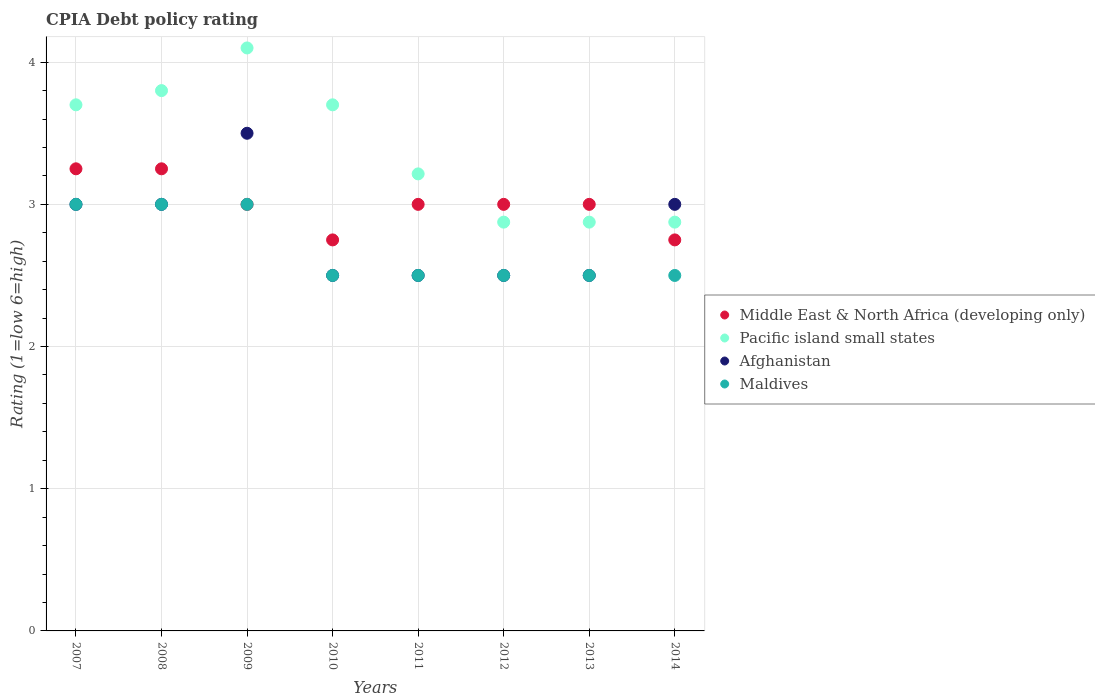How many different coloured dotlines are there?
Your answer should be very brief. 4. Across all years, what is the maximum CPIA rating in Afghanistan?
Give a very brief answer. 3.5. Across all years, what is the minimum CPIA rating in Pacific island small states?
Your answer should be compact. 2.88. In which year was the CPIA rating in Maldives maximum?
Offer a terse response. 2007. What is the average CPIA rating in Maldives per year?
Give a very brief answer. 2.69. In the year 2007, what is the difference between the CPIA rating in Maldives and CPIA rating in Pacific island small states?
Provide a short and direct response. -0.7. In how many years, is the CPIA rating in Middle East & North Africa (developing only) greater than 0.6000000000000001?
Give a very brief answer. 8. What is the ratio of the CPIA rating in Afghanistan in 2012 to that in 2014?
Offer a terse response. 0.83. Is the CPIA rating in Pacific island small states in 2008 less than that in 2013?
Your response must be concise. No. What is the difference between the highest and the second highest CPIA rating in Pacific island small states?
Give a very brief answer. 0.3. What is the difference between the highest and the lowest CPIA rating in Afghanistan?
Offer a very short reply. 1. Is it the case that in every year, the sum of the CPIA rating in Middle East & North Africa (developing only) and CPIA rating in Afghanistan  is greater than the CPIA rating in Pacific island small states?
Keep it short and to the point. Yes. Is the CPIA rating in Maldives strictly greater than the CPIA rating in Afghanistan over the years?
Offer a very short reply. No. Is the CPIA rating in Maldives strictly less than the CPIA rating in Middle East & North Africa (developing only) over the years?
Offer a terse response. No. What is the difference between two consecutive major ticks on the Y-axis?
Provide a short and direct response. 1. Are the values on the major ticks of Y-axis written in scientific E-notation?
Give a very brief answer. No. Does the graph contain any zero values?
Provide a short and direct response. No. Does the graph contain grids?
Provide a succinct answer. Yes. Where does the legend appear in the graph?
Offer a very short reply. Center right. How are the legend labels stacked?
Offer a terse response. Vertical. What is the title of the graph?
Keep it short and to the point. CPIA Debt policy rating. Does "Suriname" appear as one of the legend labels in the graph?
Make the answer very short. No. What is the label or title of the X-axis?
Keep it short and to the point. Years. What is the Rating (1=low 6=high) in Pacific island small states in 2007?
Your answer should be compact. 3.7. What is the Rating (1=low 6=high) in Maldives in 2007?
Your answer should be very brief. 3. What is the Rating (1=low 6=high) in Middle East & North Africa (developing only) in 2008?
Your response must be concise. 3.25. What is the Rating (1=low 6=high) in Maldives in 2008?
Your answer should be very brief. 3. What is the Rating (1=low 6=high) in Pacific island small states in 2009?
Provide a short and direct response. 4.1. What is the Rating (1=low 6=high) of Afghanistan in 2009?
Your response must be concise. 3.5. What is the Rating (1=low 6=high) of Maldives in 2009?
Provide a short and direct response. 3. What is the Rating (1=low 6=high) of Middle East & North Africa (developing only) in 2010?
Your answer should be very brief. 2.75. What is the Rating (1=low 6=high) in Pacific island small states in 2011?
Ensure brevity in your answer.  3.21. What is the Rating (1=low 6=high) of Afghanistan in 2011?
Keep it short and to the point. 2.5. What is the Rating (1=low 6=high) in Pacific island small states in 2012?
Ensure brevity in your answer.  2.88. What is the Rating (1=low 6=high) of Afghanistan in 2012?
Provide a short and direct response. 2.5. What is the Rating (1=low 6=high) of Middle East & North Africa (developing only) in 2013?
Offer a terse response. 3. What is the Rating (1=low 6=high) in Pacific island small states in 2013?
Give a very brief answer. 2.88. What is the Rating (1=low 6=high) of Afghanistan in 2013?
Offer a terse response. 2.5. What is the Rating (1=low 6=high) in Maldives in 2013?
Ensure brevity in your answer.  2.5. What is the Rating (1=low 6=high) of Middle East & North Africa (developing only) in 2014?
Offer a terse response. 2.75. What is the Rating (1=low 6=high) in Pacific island small states in 2014?
Ensure brevity in your answer.  2.88. What is the Rating (1=low 6=high) of Afghanistan in 2014?
Offer a terse response. 3. Across all years, what is the maximum Rating (1=low 6=high) of Pacific island small states?
Your answer should be very brief. 4.1. Across all years, what is the maximum Rating (1=low 6=high) of Afghanistan?
Ensure brevity in your answer.  3.5. Across all years, what is the minimum Rating (1=low 6=high) in Middle East & North Africa (developing only)?
Offer a terse response. 2.75. Across all years, what is the minimum Rating (1=low 6=high) of Pacific island small states?
Your answer should be compact. 2.88. Across all years, what is the minimum Rating (1=low 6=high) of Afghanistan?
Offer a terse response. 2.5. Across all years, what is the minimum Rating (1=low 6=high) in Maldives?
Your answer should be compact. 2.5. What is the total Rating (1=low 6=high) of Pacific island small states in the graph?
Give a very brief answer. 27.14. What is the difference between the Rating (1=low 6=high) in Pacific island small states in 2007 and that in 2008?
Your answer should be very brief. -0.1. What is the difference between the Rating (1=low 6=high) of Afghanistan in 2007 and that in 2009?
Offer a terse response. -0.5. What is the difference between the Rating (1=low 6=high) in Maldives in 2007 and that in 2009?
Your answer should be very brief. 0. What is the difference between the Rating (1=low 6=high) of Afghanistan in 2007 and that in 2010?
Keep it short and to the point. 0.5. What is the difference between the Rating (1=low 6=high) in Pacific island small states in 2007 and that in 2011?
Provide a succinct answer. 0.49. What is the difference between the Rating (1=low 6=high) of Middle East & North Africa (developing only) in 2007 and that in 2012?
Offer a terse response. 0.25. What is the difference between the Rating (1=low 6=high) in Pacific island small states in 2007 and that in 2012?
Your response must be concise. 0.82. What is the difference between the Rating (1=low 6=high) in Afghanistan in 2007 and that in 2012?
Your answer should be compact. 0.5. What is the difference between the Rating (1=low 6=high) of Maldives in 2007 and that in 2012?
Offer a very short reply. 0.5. What is the difference between the Rating (1=low 6=high) in Middle East & North Africa (developing only) in 2007 and that in 2013?
Your response must be concise. 0.25. What is the difference between the Rating (1=low 6=high) in Pacific island small states in 2007 and that in 2013?
Make the answer very short. 0.82. What is the difference between the Rating (1=low 6=high) in Afghanistan in 2007 and that in 2013?
Ensure brevity in your answer.  0.5. What is the difference between the Rating (1=low 6=high) of Pacific island small states in 2007 and that in 2014?
Offer a very short reply. 0.82. What is the difference between the Rating (1=low 6=high) in Maldives in 2007 and that in 2014?
Your answer should be compact. 0.5. What is the difference between the Rating (1=low 6=high) of Middle East & North Africa (developing only) in 2008 and that in 2009?
Ensure brevity in your answer.  0.25. What is the difference between the Rating (1=low 6=high) of Maldives in 2008 and that in 2010?
Ensure brevity in your answer.  0.5. What is the difference between the Rating (1=low 6=high) in Pacific island small states in 2008 and that in 2011?
Your answer should be very brief. 0.59. What is the difference between the Rating (1=low 6=high) of Afghanistan in 2008 and that in 2011?
Your response must be concise. 0.5. What is the difference between the Rating (1=low 6=high) in Maldives in 2008 and that in 2011?
Give a very brief answer. 0.5. What is the difference between the Rating (1=low 6=high) of Middle East & North Africa (developing only) in 2008 and that in 2012?
Give a very brief answer. 0.25. What is the difference between the Rating (1=low 6=high) in Pacific island small states in 2008 and that in 2012?
Your answer should be very brief. 0.93. What is the difference between the Rating (1=low 6=high) of Afghanistan in 2008 and that in 2012?
Provide a succinct answer. 0.5. What is the difference between the Rating (1=low 6=high) in Pacific island small states in 2008 and that in 2013?
Your answer should be very brief. 0.93. What is the difference between the Rating (1=low 6=high) in Afghanistan in 2008 and that in 2013?
Provide a short and direct response. 0.5. What is the difference between the Rating (1=low 6=high) of Maldives in 2008 and that in 2013?
Provide a succinct answer. 0.5. What is the difference between the Rating (1=low 6=high) of Middle East & North Africa (developing only) in 2008 and that in 2014?
Ensure brevity in your answer.  0.5. What is the difference between the Rating (1=low 6=high) in Pacific island small states in 2008 and that in 2014?
Make the answer very short. 0.93. What is the difference between the Rating (1=low 6=high) in Afghanistan in 2008 and that in 2014?
Provide a short and direct response. 0. What is the difference between the Rating (1=low 6=high) of Maldives in 2008 and that in 2014?
Offer a terse response. 0.5. What is the difference between the Rating (1=low 6=high) of Middle East & North Africa (developing only) in 2009 and that in 2010?
Make the answer very short. 0.25. What is the difference between the Rating (1=low 6=high) of Pacific island small states in 2009 and that in 2010?
Give a very brief answer. 0.4. What is the difference between the Rating (1=low 6=high) of Afghanistan in 2009 and that in 2010?
Keep it short and to the point. 1. What is the difference between the Rating (1=low 6=high) of Middle East & North Africa (developing only) in 2009 and that in 2011?
Ensure brevity in your answer.  0. What is the difference between the Rating (1=low 6=high) in Pacific island small states in 2009 and that in 2011?
Ensure brevity in your answer.  0.89. What is the difference between the Rating (1=low 6=high) of Afghanistan in 2009 and that in 2011?
Provide a short and direct response. 1. What is the difference between the Rating (1=low 6=high) of Maldives in 2009 and that in 2011?
Provide a succinct answer. 0.5. What is the difference between the Rating (1=low 6=high) in Pacific island small states in 2009 and that in 2012?
Make the answer very short. 1.23. What is the difference between the Rating (1=low 6=high) in Pacific island small states in 2009 and that in 2013?
Ensure brevity in your answer.  1.23. What is the difference between the Rating (1=low 6=high) in Afghanistan in 2009 and that in 2013?
Offer a terse response. 1. What is the difference between the Rating (1=low 6=high) in Middle East & North Africa (developing only) in 2009 and that in 2014?
Ensure brevity in your answer.  0.25. What is the difference between the Rating (1=low 6=high) of Pacific island small states in 2009 and that in 2014?
Offer a very short reply. 1.23. What is the difference between the Rating (1=low 6=high) of Middle East & North Africa (developing only) in 2010 and that in 2011?
Make the answer very short. -0.25. What is the difference between the Rating (1=low 6=high) of Pacific island small states in 2010 and that in 2011?
Provide a short and direct response. 0.49. What is the difference between the Rating (1=low 6=high) of Afghanistan in 2010 and that in 2011?
Provide a succinct answer. 0. What is the difference between the Rating (1=low 6=high) in Maldives in 2010 and that in 2011?
Give a very brief answer. 0. What is the difference between the Rating (1=low 6=high) of Middle East & North Africa (developing only) in 2010 and that in 2012?
Provide a succinct answer. -0.25. What is the difference between the Rating (1=low 6=high) of Pacific island small states in 2010 and that in 2012?
Ensure brevity in your answer.  0.82. What is the difference between the Rating (1=low 6=high) in Afghanistan in 2010 and that in 2012?
Offer a very short reply. 0. What is the difference between the Rating (1=low 6=high) of Pacific island small states in 2010 and that in 2013?
Your answer should be compact. 0.82. What is the difference between the Rating (1=low 6=high) in Afghanistan in 2010 and that in 2013?
Make the answer very short. 0. What is the difference between the Rating (1=low 6=high) of Maldives in 2010 and that in 2013?
Give a very brief answer. 0. What is the difference between the Rating (1=low 6=high) of Middle East & North Africa (developing only) in 2010 and that in 2014?
Offer a terse response. 0. What is the difference between the Rating (1=low 6=high) of Pacific island small states in 2010 and that in 2014?
Provide a short and direct response. 0.82. What is the difference between the Rating (1=low 6=high) in Pacific island small states in 2011 and that in 2012?
Ensure brevity in your answer.  0.34. What is the difference between the Rating (1=low 6=high) in Maldives in 2011 and that in 2012?
Provide a short and direct response. 0. What is the difference between the Rating (1=low 6=high) in Middle East & North Africa (developing only) in 2011 and that in 2013?
Give a very brief answer. 0. What is the difference between the Rating (1=low 6=high) in Pacific island small states in 2011 and that in 2013?
Your answer should be compact. 0.34. What is the difference between the Rating (1=low 6=high) in Maldives in 2011 and that in 2013?
Your answer should be compact. 0. What is the difference between the Rating (1=low 6=high) of Pacific island small states in 2011 and that in 2014?
Give a very brief answer. 0.34. What is the difference between the Rating (1=low 6=high) of Afghanistan in 2011 and that in 2014?
Your response must be concise. -0.5. What is the difference between the Rating (1=low 6=high) of Maldives in 2011 and that in 2014?
Offer a very short reply. 0. What is the difference between the Rating (1=low 6=high) of Pacific island small states in 2012 and that in 2013?
Your answer should be very brief. 0. What is the difference between the Rating (1=low 6=high) of Afghanistan in 2012 and that in 2013?
Make the answer very short. 0. What is the difference between the Rating (1=low 6=high) in Middle East & North Africa (developing only) in 2012 and that in 2014?
Your response must be concise. 0.25. What is the difference between the Rating (1=low 6=high) of Pacific island small states in 2012 and that in 2014?
Ensure brevity in your answer.  0. What is the difference between the Rating (1=low 6=high) in Afghanistan in 2012 and that in 2014?
Offer a terse response. -0.5. What is the difference between the Rating (1=low 6=high) in Middle East & North Africa (developing only) in 2013 and that in 2014?
Your response must be concise. 0.25. What is the difference between the Rating (1=low 6=high) of Middle East & North Africa (developing only) in 2007 and the Rating (1=low 6=high) of Pacific island small states in 2008?
Provide a short and direct response. -0.55. What is the difference between the Rating (1=low 6=high) of Middle East & North Africa (developing only) in 2007 and the Rating (1=low 6=high) of Afghanistan in 2008?
Ensure brevity in your answer.  0.25. What is the difference between the Rating (1=low 6=high) in Pacific island small states in 2007 and the Rating (1=low 6=high) in Afghanistan in 2008?
Your answer should be very brief. 0.7. What is the difference between the Rating (1=low 6=high) of Pacific island small states in 2007 and the Rating (1=low 6=high) of Maldives in 2008?
Provide a succinct answer. 0.7. What is the difference between the Rating (1=low 6=high) in Afghanistan in 2007 and the Rating (1=low 6=high) in Maldives in 2008?
Make the answer very short. 0. What is the difference between the Rating (1=low 6=high) of Middle East & North Africa (developing only) in 2007 and the Rating (1=low 6=high) of Pacific island small states in 2009?
Provide a succinct answer. -0.85. What is the difference between the Rating (1=low 6=high) in Middle East & North Africa (developing only) in 2007 and the Rating (1=low 6=high) in Afghanistan in 2009?
Your answer should be very brief. -0.25. What is the difference between the Rating (1=low 6=high) of Pacific island small states in 2007 and the Rating (1=low 6=high) of Afghanistan in 2009?
Give a very brief answer. 0.2. What is the difference between the Rating (1=low 6=high) of Pacific island small states in 2007 and the Rating (1=low 6=high) of Maldives in 2009?
Provide a short and direct response. 0.7. What is the difference between the Rating (1=low 6=high) in Afghanistan in 2007 and the Rating (1=low 6=high) in Maldives in 2009?
Your response must be concise. 0. What is the difference between the Rating (1=low 6=high) in Middle East & North Africa (developing only) in 2007 and the Rating (1=low 6=high) in Pacific island small states in 2010?
Keep it short and to the point. -0.45. What is the difference between the Rating (1=low 6=high) of Pacific island small states in 2007 and the Rating (1=low 6=high) of Afghanistan in 2010?
Keep it short and to the point. 1.2. What is the difference between the Rating (1=low 6=high) of Middle East & North Africa (developing only) in 2007 and the Rating (1=low 6=high) of Pacific island small states in 2011?
Provide a short and direct response. 0.04. What is the difference between the Rating (1=low 6=high) in Middle East & North Africa (developing only) in 2007 and the Rating (1=low 6=high) in Afghanistan in 2011?
Provide a succinct answer. 0.75. What is the difference between the Rating (1=low 6=high) of Middle East & North Africa (developing only) in 2007 and the Rating (1=low 6=high) of Maldives in 2011?
Offer a very short reply. 0.75. What is the difference between the Rating (1=low 6=high) of Afghanistan in 2007 and the Rating (1=low 6=high) of Maldives in 2011?
Your response must be concise. 0.5. What is the difference between the Rating (1=low 6=high) of Middle East & North Africa (developing only) in 2007 and the Rating (1=low 6=high) of Afghanistan in 2012?
Keep it short and to the point. 0.75. What is the difference between the Rating (1=low 6=high) of Middle East & North Africa (developing only) in 2007 and the Rating (1=low 6=high) of Maldives in 2012?
Your response must be concise. 0.75. What is the difference between the Rating (1=low 6=high) in Pacific island small states in 2007 and the Rating (1=low 6=high) in Afghanistan in 2012?
Make the answer very short. 1.2. What is the difference between the Rating (1=low 6=high) of Pacific island small states in 2007 and the Rating (1=low 6=high) of Maldives in 2012?
Give a very brief answer. 1.2. What is the difference between the Rating (1=low 6=high) of Afghanistan in 2007 and the Rating (1=low 6=high) of Maldives in 2012?
Your response must be concise. 0.5. What is the difference between the Rating (1=low 6=high) of Middle East & North Africa (developing only) in 2007 and the Rating (1=low 6=high) of Afghanistan in 2013?
Offer a very short reply. 0.75. What is the difference between the Rating (1=low 6=high) of Pacific island small states in 2007 and the Rating (1=low 6=high) of Afghanistan in 2013?
Ensure brevity in your answer.  1.2. What is the difference between the Rating (1=low 6=high) in Pacific island small states in 2007 and the Rating (1=low 6=high) in Maldives in 2013?
Make the answer very short. 1.2. What is the difference between the Rating (1=low 6=high) of Middle East & North Africa (developing only) in 2007 and the Rating (1=low 6=high) of Pacific island small states in 2014?
Your response must be concise. 0.38. What is the difference between the Rating (1=low 6=high) of Middle East & North Africa (developing only) in 2007 and the Rating (1=low 6=high) of Afghanistan in 2014?
Provide a short and direct response. 0.25. What is the difference between the Rating (1=low 6=high) of Middle East & North Africa (developing only) in 2007 and the Rating (1=low 6=high) of Maldives in 2014?
Offer a terse response. 0.75. What is the difference between the Rating (1=low 6=high) of Pacific island small states in 2007 and the Rating (1=low 6=high) of Afghanistan in 2014?
Provide a short and direct response. 0.7. What is the difference between the Rating (1=low 6=high) of Pacific island small states in 2007 and the Rating (1=low 6=high) of Maldives in 2014?
Provide a succinct answer. 1.2. What is the difference between the Rating (1=low 6=high) in Afghanistan in 2007 and the Rating (1=low 6=high) in Maldives in 2014?
Your response must be concise. 0.5. What is the difference between the Rating (1=low 6=high) of Middle East & North Africa (developing only) in 2008 and the Rating (1=low 6=high) of Pacific island small states in 2009?
Keep it short and to the point. -0.85. What is the difference between the Rating (1=low 6=high) in Pacific island small states in 2008 and the Rating (1=low 6=high) in Maldives in 2009?
Your answer should be very brief. 0.8. What is the difference between the Rating (1=low 6=high) in Afghanistan in 2008 and the Rating (1=low 6=high) in Maldives in 2009?
Offer a very short reply. 0. What is the difference between the Rating (1=low 6=high) of Middle East & North Africa (developing only) in 2008 and the Rating (1=low 6=high) of Pacific island small states in 2010?
Give a very brief answer. -0.45. What is the difference between the Rating (1=low 6=high) in Middle East & North Africa (developing only) in 2008 and the Rating (1=low 6=high) in Afghanistan in 2010?
Offer a terse response. 0.75. What is the difference between the Rating (1=low 6=high) of Middle East & North Africa (developing only) in 2008 and the Rating (1=low 6=high) of Maldives in 2010?
Provide a short and direct response. 0.75. What is the difference between the Rating (1=low 6=high) in Pacific island small states in 2008 and the Rating (1=low 6=high) in Afghanistan in 2010?
Your answer should be very brief. 1.3. What is the difference between the Rating (1=low 6=high) of Afghanistan in 2008 and the Rating (1=low 6=high) of Maldives in 2010?
Offer a terse response. 0.5. What is the difference between the Rating (1=low 6=high) of Middle East & North Africa (developing only) in 2008 and the Rating (1=low 6=high) of Pacific island small states in 2011?
Keep it short and to the point. 0.04. What is the difference between the Rating (1=low 6=high) in Pacific island small states in 2008 and the Rating (1=low 6=high) in Afghanistan in 2011?
Provide a short and direct response. 1.3. What is the difference between the Rating (1=low 6=high) of Pacific island small states in 2008 and the Rating (1=low 6=high) of Maldives in 2011?
Offer a terse response. 1.3. What is the difference between the Rating (1=low 6=high) of Middle East & North Africa (developing only) in 2008 and the Rating (1=low 6=high) of Maldives in 2012?
Ensure brevity in your answer.  0.75. What is the difference between the Rating (1=low 6=high) in Pacific island small states in 2008 and the Rating (1=low 6=high) in Maldives in 2012?
Offer a terse response. 1.3. What is the difference between the Rating (1=low 6=high) of Afghanistan in 2008 and the Rating (1=low 6=high) of Maldives in 2012?
Your answer should be very brief. 0.5. What is the difference between the Rating (1=low 6=high) in Middle East & North Africa (developing only) in 2008 and the Rating (1=low 6=high) in Pacific island small states in 2013?
Provide a succinct answer. 0.38. What is the difference between the Rating (1=low 6=high) of Middle East & North Africa (developing only) in 2008 and the Rating (1=low 6=high) of Afghanistan in 2013?
Ensure brevity in your answer.  0.75. What is the difference between the Rating (1=low 6=high) of Pacific island small states in 2008 and the Rating (1=low 6=high) of Afghanistan in 2013?
Offer a very short reply. 1.3. What is the difference between the Rating (1=low 6=high) in Pacific island small states in 2008 and the Rating (1=low 6=high) in Maldives in 2013?
Offer a very short reply. 1.3. What is the difference between the Rating (1=low 6=high) of Middle East & North Africa (developing only) in 2008 and the Rating (1=low 6=high) of Pacific island small states in 2014?
Provide a short and direct response. 0.38. What is the difference between the Rating (1=low 6=high) of Middle East & North Africa (developing only) in 2008 and the Rating (1=low 6=high) of Maldives in 2014?
Provide a succinct answer. 0.75. What is the difference between the Rating (1=low 6=high) in Middle East & North Africa (developing only) in 2009 and the Rating (1=low 6=high) in Pacific island small states in 2010?
Give a very brief answer. -0.7. What is the difference between the Rating (1=low 6=high) of Middle East & North Africa (developing only) in 2009 and the Rating (1=low 6=high) of Afghanistan in 2010?
Provide a succinct answer. 0.5. What is the difference between the Rating (1=low 6=high) of Middle East & North Africa (developing only) in 2009 and the Rating (1=low 6=high) of Maldives in 2010?
Give a very brief answer. 0.5. What is the difference between the Rating (1=low 6=high) in Pacific island small states in 2009 and the Rating (1=low 6=high) in Afghanistan in 2010?
Offer a very short reply. 1.6. What is the difference between the Rating (1=low 6=high) in Pacific island small states in 2009 and the Rating (1=low 6=high) in Maldives in 2010?
Ensure brevity in your answer.  1.6. What is the difference between the Rating (1=low 6=high) in Afghanistan in 2009 and the Rating (1=low 6=high) in Maldives in 2010?
Keep it short and to the point. 1. What is the difference between the Rating (1=low 6=high) of Middle East & North Africa (developing only) in 2009 and the Rating (1=low 6=high) of Pacific island small states in 2011?
Your response must be concise. -0.21. What is the difference between the Rating (1=low 6=high) in Middle East & North Africa (developing only) in 2009 and the Rating (1=low 6=high) in Afghanistan in 2011?
Your answer should be compact. 0.5. What is the difference between the Rating (1=low 6=high) in Middle East & North Africa (developing only) in 2009 and the Rating (1=low 6=high) in Maldives in 2011?
Give a very brief answer. 0.5. What is the difference between the Rating (1=low 6=high) in Pacific island small states in 2009 and the Rating (1=low 6=high) in Afghanistan in 2011?
Provide a short and direct response. 1.6. What is the difference between the Rating (1=low 6=high) in Afghanistan in 2009 and the Rating (1=low 6=high) in Maldives in 2011?
Provide a short and direct response. 1. What is the difference between the Rating (1=low 6=high) of Middle East & North Africa (developing only) in 2009 and the Rating (1=low 6=high) of Maldives in 2012?
Keep it short and to the point. 0.5. What is the difference between the Rating (1=low 6=high) of Pacific island small states in 2009 and the Rating (1=low 6=high) of Afghanistan in 2012?
Ensure brevity in your answer.  1.6. What is the difference between the Rating (1=low 6=high) in Pacific island small states in 2009 and the Rating (1=low 6=high) in Maldives in 2012?
Offer a terse response. 1.6. What is the difference between the Rating (1=low 6=high) in Middle East & North Africa (developing only) in 2009 and the Rating (1=low 6=high) in Afghanistan in 2013?
Provide a short and direct response. 0.5. What is the difference between the Rating (1=low 6=high) of Middle East & North Africa (developing only) in 2009 and the Rating (1=low 6=high) of Maldives in 2013?
Your answer should be compact. 0.5. What is the difference between the Rating (1=low 6=high) in Pacific island small states in 2009 and the Rating (1=low 6=high) in Afghanistan in 2013?
Provide a short and direct response. 1.6. What is the difference between the Rating (1=low 6=high) in Afghanistan in 2009 and the Rating (1=low 6=high) in Maldives in 2013?
Give a very brief answer. 1. What is the difference between the Rating (1=low 6=high) in Middle East & North Africa (developing only) in 2009 and the Rating (1=low 6=high) in Afghanistan in 2014?
Make the answer very short. 0. What is the difference between the Rating (1=low 6=high) of Middle East & North Africa (developing only) in 2009 and the Rating (1=low 6=high) of Maldives in 2014?
Keep it short and to the point. 0.5. What is the difference between the Rating (1=low 6=high) of Pacific island small states in 2009 and the Rating (1=low 6=high) of Maldives in 2014?
Your answer should be very brief. 1.6. What is the difference between the Rating (1=low 6=high) of Middle East & North Africa (developing only) in 2010 and the Rating (1=low 6=high) of Pacific island small states in 2011?
Provide a short and direct response. -0.46. What is the difference between the Rating (1=low 6=high) of Middle East & North Africa (developing only) in 2010 and the Rating (1=low 6=high) of Pacific island small states in 2012?
Give a very brief answer. -0.12. What is the difference between the Rating (1=low 6=high) of Middle East & North Africa (developing only) in 2010 and the Rating (1=low 6=high) of Afghanistan in 2012?
Give a very brief answer. 0.25. What is the difference between the Rating (1=low 6=high) in Afghanistan in 2010 and the Rating (1=low 6=high) in Maldives in 2012?
Ensure brevity in your answer.  0. What is the difference between the Rating (1=low 6=high) in Middle East & North Africa (developing only) in 2010 and the Rating (1=low 6=high) in Pacific island small states in 2013?
Make the answer very short. -0.12. What is the difference between the Rating (1=low 6=high) in Middle East & North Africa (developing only) in 2010 and the Rating (1=low 6=high) in Afghanistan in 2013?
Your response must be concise. 0.25. What is the difference between the Rating (1=low 6=high) of Middle East & North Africa (developing only) in 2010 and the Rating (1=low 6=high) of Maldives in 2013?
Provide a succinct answer. 0.25. What is the difference between the Rating (1=low 6=high) in Pacific island small states in 2010 and the Rating (1=low 6=high) in Maldives in 2013?
Offer a terse response. 1.2. What is the difference between the Rating (1=low 6=high) in Middle East & North Africa (developing only) in 2010 and the Rating (1=low 6=high) in Pacific island small states in 2014?
Make the answer very short. -0.12. What is the difference between the Rating (1=low 6=high) in Pacific island small states in 2010 and the Rating (1=low 6=high) in Maldives in 2014?
Offer a very short reply. 1.2. What is the difference between the Rating (1=low 6=high) in Middle East & North Africa (developing only) in 2011 and the Rating (1=low 6=high) in Pacific island small states in 2012?
Offer a terse response. 0.12. What is the difference between the Rating (1=low 6=high) in Middle East & North Africa (developing only) in 2011 and the Rating (1=low 6=high) in Maldives in 2012?
Offer a terse response. 0.5. What is the difference between the Rating (1=low 6=high) in Pacific island small states in 2011 and the Rating (1=low 6=high) in Afghanistan in 2012?
Give a very brief answer. 0.71. What is the difference between the Rating (1=low 6=high) of Afghanistan in 2011 and the Rating (1=low 6=high) of Maldives in 2012?
Your answer should be compact. 0. What is the difference between the Rating (1=low 6=high) in Middle East & North Africa (developing only) in 2011 and the Rating (1=low 6=high) in Pacific island small states in 2013?
Your response must be concise. 0.12. What is the difference between the Rating (1=low 6=high) in Middle East & North Africa (developing only) in 2011 and the Rating (1=low 6=high) in Afghanistan in 2013?
Offer a terse response. 0.5. What is the difference between the Rating (1=low 6=high) in Middle East & North Africa (developing only) in 2011 and the Rating (1=low 6=high) in Maldives in 2013?
Your answer should be very brief. 0.5. What is the difference between the Rating (1=low 6=high) in Middle East & North Africa (developing only) in 2011 and the Rating (1=low 6=high) in Pacific island small states in 2014?
Your answer should be compact. 0.12. What is the difference between the Rating (1=low 6=high) of Middle East & North Africa (developing only) in 2011 and the Rating (1=low 6=high) of Afghanistan in 2014?
Offer a terse response. 0. What is the difference between the Rating (1=low 6=high) in Middle East & North Africa (developing only) in 2011 and the Rating (1=low 6=high) in Maldives in 2014?
Keep it short and to the point. 0.5. What is the difference between the Rating (1=low 6=high) of Pacific island small states in 2011 and the Rating (1=low 6=high) of Afghanistan in 2014?
Your answer should be very brief. 0.21. What is the difference between the Rating (1=low 6=high) in Afghanistan in 2011 and the Rating (1=low 6=high) in Maldives in 2014?
Your answer should be very brief. 0. What is the difference between the Rating (1=low 6=high) in Middle East & North Africa (developing only) in 2012 and the Rating (1=low 6=high) in Afghanistan in 2013?
Give a very brief answer. 0.5. What is the difference between the Rating (1=low 6=high) of Middle East & North Africa (developing only) in 2012 and the Rating (1=low 6=high) of Maldives in 2013?
Keep it short and to the point. 0.5. What is the difference between the Rating (1=low 6=high) in Pacific island small states in 2012 and the Rating (1=low 6=high) in Afghanistan in 2013?
Ensure brevity in your answer.  0.38. What is the difference between the Rating (1=low 6=high) of Pacific island small states in 2012 and the Rating (1=low 6=high) of Maldives in 2013?
Your response must be concise. 0.38. What is the difference between the Rating (1=low 6=high) in Middle East & North Africa (developing only) in 2012 and the Rating (1=low 6=high) in Afghanistan in 2014?
Offer a very short reply. 0. What is the difference between the Rating (1=low 6=high) of Middle East & North Africa (developing only) in 2012 and the Rating (1=low 6=high) of Maldives in 2014?
Your answer should be very brief. 0.5. What is the difference between the Rating (1=low 6=high) in Pacific island small states in 2012 and the Rating (1=low 6=high) in Afghanistan in 2014?
Provide a short and direct response. -0.12. What is the difference between the Rating (1=low 6=high) in Pacific island small states in 2012 and the Rating (1=low 6=high) in Maldives in 2014?
Keep it short and to the point. 0.38. What is the difference between the Rating (1=low 6=high) in Afghanistan in 2012 and the Rating (1=low 6=high) in Maldives in 2014?
Keep it short and to the point. 0. What is the difference between the Rating (1=low 6=high) of Middle East & North Africa (developing only) in 2013 and the Rating (1=low 6=high) of Pacific island small states in 2014?
Give a very brief answer. 0.12. What is the difference between the Rating (1=low 6=high) of Middle East & North Africa (developing only) in 2013 and the Rating (1=low 6=high) of Maldives in 2014?
Ensure brevity in your answer.  0.5. What is the difference between the Rating (1=low 6=high) of Pacific island small states in 2013 and the Rating (1=low 6=high) of Afghanistan in 2014?
Offer a terse response. -0.12. What is the difference between the Rating (1=low 6=high) in Pacific island small states in 2013 and the Rating (1=low 6=high) in Maldives in 2014?
Give a very brief answer. 0.38. What is the difference between the Rating (1=low 6=high) in Afghanistan in 2013 and the Rating (1=low 6=high) in Maldives in 2014?
Your answer should be very brief. 0. What is the average Rating (1=low 6=high) in Pacific island small states per year?
Provide a short and direct response. 3.39. What is the average Rating (1=low 6=high) in Afghanistan per year?
Offer a terse response. 2.81. What is the average Rating (1=low 6=high) of Maldives per year?
Your response must be concise. 2.69. In the year 2007, what is the difference between the Rating (1=low 6=high) of Middle East & North Africa (developing only) and Rating (1=low 6=high) of Pacific island small states?
Ensure brevity in your answer.  -0.45. In the year 2007, what is the difference between the Rating (1=low 6=high) in Pacific island small states and Rating (1=low 6=high) in Maldives?
Keep it short and to the point. 0.7. In the year 2007, what is the difference between the Rating (1=low 6=high) in Afghanistan and Rating (1=low 6=high) in Maldives?
Your answer should be very brief. 0. In the year 2008, what is the difference between the Rating (1=low 6=high) of Middle East & North Africa (developing only) and Rating (1=low 6=high) of Pacific island small states?
Make the answer very short. -0.55. In the year 2008, what is the difference between the Rating (1=low 6=high) in Middle East & North Africa (developing only) and Rating (1=low 6=high) in Maldives?
Keep it short and to the point. 0.25. In the year 2008, what is the difference between the Rating (1=low 6=high) in Afghanistan and Rating (1=low 6=high) in Maldives?
Provide a short and direct response. 0. In the year 2009, what is the difference between the Rating (1=low 6=high) in Middle East & North Africa (developing only) and Rating (1=low 6=high) in Pacific island small states?
Make the answer very short. -1.1. In the year 2009, what is the difference between the Rating (1=low 6=high) of Middle East & North Africa (developing only) and Rating (1=low 6=high) of Afghanistan?
Keep it short and to the point. -0.5. In the year 2009, what is the difference between the Rating (1=low 6=high) in Middle East & North Africa (developing only) and Rating (1=low 6=high) in Maldives?
Make the answer very short. 0. In the year 2009, what is the difference between the Rating (1=low 6=high) in Pacific island small states and Rating (1=low 6=high) in Maldives?
Offer a terse response. 1.1. In the year 2010, what is the difference between the Rating (1=low 6=high) of Middle East & North Africa (developing only) and Rating (1=low 6=high) of Pacific island small states?
Provide a short and direct response. -0.95. In the year 2010, what is the difference between the Rating (1=low 6=high) in Middle East & North Africa (developing only) and Rating (1=low 6=high) in Maldives?
Ensure brevity in your answer.  0.25. In the year 2011, what is the difference between the Rating (1=low 6=high) of Middle East & North Africa (developing only) and Rating (1=low 6=high) of Pacific island small states?
Make the answer very short. -0.21. In the year 2011, what is the difference between the Rating (1=low 6=high) in Middle East & North Africa (developing only) and Rating (1=low 6=high) in Maldives?
Your answer should be very brief. 0.5. In the year 2012, what is the difference between the Rating (1=low 6=high) of Middle East & North Africa (developing only) and Rating (1=low 6=high) of Pacific island small states?
Your answer should be compact. 0.12. In the year 2012, what is the difference between the Rating (1=low 6=high) of Middle East & North Africa (developing only) and Rating (1=low 6=high) of Maldives?
Your answer should be compact. 0.5. In the year 2012, what is the difference between the Rating (1=low 6=high) of Pacific island small states and Rating (1=low 6=high) of Afghanistan?
Give a very brief answer. 0.38. In the year 2012, what is the difference between the Rating (1=low 6=high) in Pacific island small states and Rating (1=low 6=high) in Maldives?
Make the answer very short. 0.38. In the year 2013, what is the difference between the Rating (1=low 6=high) of Afghanistan and Rating (1=low 6=high) of Maldives?
Your answer should be compact. 0. In the year 2014, what is the difference between the Rating (1=low 6=high) of Middle East & North Africa (developing only) and Rating (1=low 6=high) of Pacific island small states?
Provide a succinct answer. -0.12. In the year 2014, what is the difference between the Rating (1=low 6=high) of Pacific island small states and Rating (1=low 6=high) of Afghanistan?
Offer a terse response. -0.12. In the year 2014, what is the difference between the Rating (1=low 6=high) in Afghanistan and Rating (1=low 6=high) in Maldives?
Your answer should be very brief. 0.5. What is the ratio of the Rating (1=low 6=high) in Middle East & North Africa (developing only) in 2007 to that in 2008?
Ensure brevity in your answer.  1. What is the ratio of the Rating (1=low 6=high) in Pacific island small states in 2007 to that in 2008?
Your answer should be compact. 0.97. What is the ratio of the Rating (1=low 6=high) of Afghanistan in 2007 to that in 2008?
Your response must be concise. 1. What is the ratio of the Rating (1=low 6=high) in Maldives in 2007 to that in 2008?
Give a very brief answer. 1. What is the ratio of the Rating (1=low 6=high) in Pacific island small states in 2007 to that in 2009?
Ensure brevity in your answer.  0.9. What is the ratio of the Rating (1=low 6=high) in Middle East & North Africa (developing only) in 2007 to that in 2010?
Your answer should be compact. 1.18. What is the ratio of the Rating (1=low 6=high) of Pacific island small states in 2007 to that in 2010?
Keep it short and to the point. 1. What is the ratio of the Rating (1=low 6=high) in Afghanistan in 2007 to that in 2010?
Your response must be concise. 1.2. What is the ratio of the Rating (1=low 6=high) in Pacific island small states in 2007 to that in 2011?
Ensure brevity in your answer.  1.15. What is the ratio of the Rating (1=low 6=high) in Afghanistan in 2007 to that in 2011?
Your answer should be compact. 1.2. What is the ratio of the Rating (1=low 6=high) in Pacific island small states in 2007 to that in 2012?
Your answer should be very brief. 1.29. What is the ratio of the Rating (1=low 6=high) in Afghanistan in 2007 to that in 2012?
Provide a succinct answer. 1.2. What is the ratio of the Rating (1=low 6=high) in Maldives in 2007 to that in 2012?
Provide a succinct answer. 1.2. What is the ratio of the Rating (1=low 6=high) in Pacific island small states in 2007 to that in 2013?
Provide a succinct answer. 1.29. What is the ratio of the Rating (1=low 6=high) in Middle East & North Africa (developing only) in 2007 to that in 2014?
Make the answer very short. 1.18. What is the ratio of the Rating (1=low 6=high) of Pacific island small states in 2007 to that in 2014?
Your response must be concise. 1.29. What is the ratio of the Rating (1=low 6=high) in Maldives in 2007 to that in 2014?
Ensure brevity in your answer.  1.2. What is the ratio of the Rating (1=low 6=high) of Middle East & North Africa (developing only) in 2008 to that in 2009?
Offer a terse response. 1.08. What is the ratio of the Rating (1=low 6=high) of Pacific island small states in 2008 to that in 2009?
Keep it short and to the point. 0.93. What is the ratio of the Rating (1=low 6=high) in Afghanistan in 2008 to that in 2009?
Offer a terse response. 0.86. What is the ratio of the Rating (1=low 6=high) of Middle East & North Africa (developing only) in 2008 to that in 2010?
Your answer should be very brief. 1.18. What is the ratio of the Rating (1=low 6=high) of Pacific island small states in 2008 to that in 2010?
Your answer should be very brief. 1.03. What is the ratio of the Rating (1=low 6=high) of Afghanistan in 2008 to that in 2010?
Make the answer very short. 1.2. What is the ratio of the Rating (1=low 6=high) of Maldives in 2008 to that in 2010?
Offer a very short reply. 1.2. What is the ratio of the Rating (1=low 6=high) in Pacific island small states in 2008 to that in 2011?
Give a very brief answer. 1.18. What is the ratio of the Rating (1=low 6=high) in Pacific island small states in 2008 to that in 2012?
Your response must be concise. 1.32. What is the ratio of the Rating (1=low 6=high) in Middle East & North Africa (developing only) in 2008 to that in 2013?
Your answer should be compact. 1.08. What is the ratio of the Rating (1=low 6=high) of Pacific island small states in 2008 to that in 2013?
Ensure brevity in your answer.  1.32. What is the ratio of the Rating (1=low 6=high) in Afghanistan in 2008 to that in 2013?
Offer a terse response. 1.2. What is the ratio of the Rating (1=low 6=high) of Middle East & North Africa (developing only) in 2008 to that in 2014?
Make the answer very short. 1.18. What is the ratio of the Rating (1=low 6=high) of Pacific island small states in 2008 to that in 2014?
Provide a short and direct response. 1.32. What is the ratio of the Rating (1=low 6=high) of Maldives in 2008 to that in 2014?
Provide a succinct answer. 1.2. What is the ratio of the Rating (1=low 6=high) in Pacific island small states in 2009 to that in 2010?
Make the answer very short. 1.11. What is the ratio of the Rating (1=low 6=high) of Maldives in 2009 to that in 2010?
Your answer should be very brief. 1.2. What is the ratio of the Rating (1=low 6=high) in Pacific island small states in 2009 to that in 2011?
Ensure brevity in your answer.  1.28. What is the ratio of the Rating (1=low 6=high) in Middle East & North Africa (developing only) in 2009 to that in 2012?
Keep it short and to the point. 1. What is the ratio of the Rating (1=low 6=high) of Pacific island small states in 2009 to that in 2012?
Your response must be concise. 1.43. What is the ratio of the Rating (1=low 6=high) of Pacific island small states in 2009 to that in 2013?
Give a very brief answer. 1.43. What is the ratio of the Rating (1=low 6=high) of Pacific island small states in 2009 to that in 2014?
Your answer should be very brief. 1.43. What is the ratio of the Rating (1=low 6=high) in Afghanistan in 2009 to that in 2014?
Your response must be concise. 1.17. What is the ratio of the Rating (1=low 6=high) in Middle East & North Africa (developing only) in 2010 to that in 2011?
Your answer should be very brief. 0.92. What is the ratio of the Rating (1=low 6=high) of Pacific island small states in 2010 to that in 2011?
Your answer should be very brief. 1.15. What is the ratio of the Rating (1=low 6=high) of Afghanistan in 2010 to that in 2011?
Offer a terse response. 1. What is the ratio of the Rating (1=low 6=high) of Pacific island small states in 2010 to that in 2012?
Offer a terse response. 1.29. What is the ratio of the Rating (1=low 6=high) in Afghanistan in 2010 to that in 2012?
Provide a short and direct response. 1. What is the ratio of the Rating (1=low 6=high) in Pacific island small states in 2010 to that in 2013?
Offer a terse response. 1.29. What is the ratio of the Rating (1=low 6=high) of Maldives in 2010 to that in 2013?
Make the answer very short. 1. What is the ratio of the Rating (1=low 6=high) of Pacific island small states in 2010 to that in 2014?
Keep it short and to the point. 1.29. What is the ratio of the Rating (1=low 6=high) of Afghanistan in 2010 to that in 2014?
Provide a short and direct response. 0.83. What is the ratio of the Rating (1=low 6=high) in Middle East & North Africa (developing only) in 2011 to that in 2012?
Make the answer very short. 1. What is the ratio of the Rating (1=low 6=high) in Pacific island small states in 2011 to that in 2012?
Ensure brevity in your answer.  1.12. What is the ratio of the Rating (1=low 6=high) in Afghanistan in 2011 to that in 2012?
Make the answer very short. 1. What is the ratio of the Rating (1=low 6=high) in Pacific island small states in 2011 to that in 2013?
Give a very brief answer. 1.12. What is the ratio of the Rating (1=low 6=high) in Afghanistan in 2011 to that in 2013?
Make the answer very short. 1. What is the ratio of the Rating (1=low 6=high) in Pacific island small states in 2011 to that in 2014?
Make the answer very short. 1.12. What is the ratio of the Rating (1=low 6=high) of Afghanistan in 2011 to that in 2014?
Keep it short and to the point. 0.83. What is the ratio of the Rating (1=low 6=high) of Maldives in 2011 to that in 2014?
Your answer should be very brief. 1. What is the ratio of the Rating (1=low 6=high) in Middle East & North Africa (developing only) in 2012 to that in 2013?
Offer a terse response. 1. What is the ratio of the Rating (1=low 6=high) of Afghanistan in 2012 to that in 2013?
Your answer should be very brief. 1. What is the ratio of the Rating (1=low 6=high) in Afghanistan in 2012 to that in 2014?
Your response must be concise. 0.83. What is the ratio of the Rating (1=low 6=high) in Maldives in 2012 to that in 2014?
Keep it short and to the point. 1. What is the ratio of the Rating (1=low 6=high) in Maldives in 2013 to that in 2014?
Provide a short and direct response. 1. What is the difference between the highest and the second highest Rating (1=low 6=high) in Middle East & North Africa (developing only)?
Provide a short and direct response. 0. What is the difference between the highest and the second highest Rating (1=low 6=high) in Afghanistan?
Provide a succinct answer. 0.5. What is the difference between the highest and the lowest Rating (1=low 6=high) of Middle East & North Africa (developing only)?
Your answer should be very brief. 0.5. What is the difference between the highest and the lowest Rating (1=low 6=high) in Pacific island small states?
Make the answer very short. 1.23. What is the difference between the highest and the lowest Rating (1=low 6=high) in Afghanistan?
Offer a very short reply. 1. 